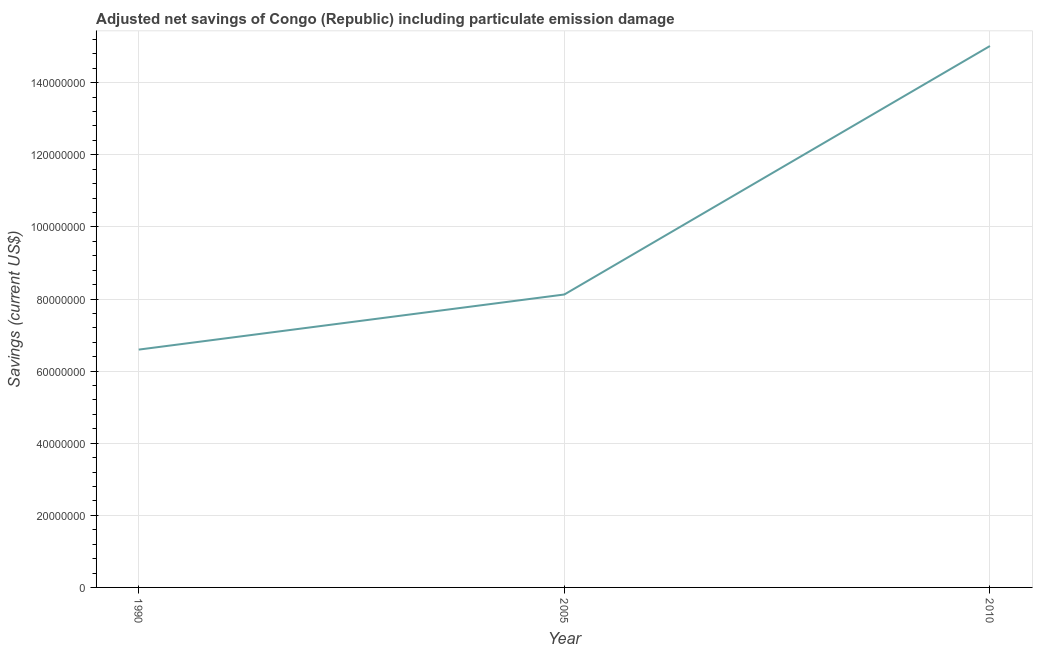What is the adjusted net savings in 2010?
Your response must be concise. 1.50e+08. Across all years, what is the maximum adjusted net savings?
Ensure brevity in your answer.  1.50e+08. Across all years, what is the minimum adjusted net savings?
Your answer should be very brief. 6.60e+07. In which year was the adjusted net savings maximum?
Your answer should be very brief. 2010. In which year was the adjusted net savings minimum?
Offer a very short reply. 1990. What is the sum of the adjusted net savings?
Keep it short and to the point. 2.97e+08. What is the difference between the adjusted net savings in 1990 and 2010?
Give a very brief answer. -8.42e+07. What is the average adjusted net savings per year?
Provide a succinct answer. 9.91e+07. What is the median adjusted net savings?
Keep it short and to the point. 8.13e+07. In how many years, is the adjusted net savings greater than 28000000 US$?
Your answer should be very brief. 3. Do a majority of the years between 2010 and 2005 (inclusive) have adjusted net savings greater than 8000000 US$?
Make the answer very short. No. What is the ratio of the adjusted net savings in 2005 to that in 2010?
Provide a short and direct response. 0.54. Is the adjusted net savings in 1990 less than that in 2005?
Make the answer very short. Yes. Is the difference between the adjusted net savings in 2005 and 2010 greater than the difference between any two years?
Your response must be concise. No. What is the difference between the highest and the second highest adjusted net savings?
Ensure brevity in your answer.  6.89e+07. What is the difference between the highest and the lowest adjusted net savings?
Make the answer very short. 8.42e+07. How many lines are there?
Your response must be concise. 1. Are the values on the major ticks of Y-axis written in scientific E-notation?
Offer a terse response. No. Does the graph contain grids?
Keep it short and to the point. Yes. What is the title of the graph?
Your answer should be very brief. Adjusted net savings of Congo (Republic) including particulate emission damage. What is the label or title of the Y-axis?
Your response must be concise. Savings (current US$). What is the Savings (current US$) in 1990?
Provide a succinct answer. 6.60e+07. What is the Savings (current US$) in 2005?
Provide a succinct answer. 8.13e+07. What is the Savings (current US$) in 2010?
Make the answer very short. 1.50e+08. What is the difference between the Savings (current US$) in 1990 and 2005?
Provide a short and direct response. -1.53e+07. What is the difference between the Savings (current US$) in 1990 and 2010?
Your response must be concise. -8.42e+07. What is the difference between the Savings (current US$) in 2005 and 2010?
Provide a short and direct response. -6.89e+07. What is the ratio of the Savings (current US$) in 1990 to that in 2005?
Your answer should be very brief. 0.81. What is the ratio of the Savings (current US$) in 1990 to that in 2010?
Provide a short and direct response. 0.44. What is the ratio of the Savings (current US$) in 2005 to that in 2010?
Your answer should be compact. 0.54. 